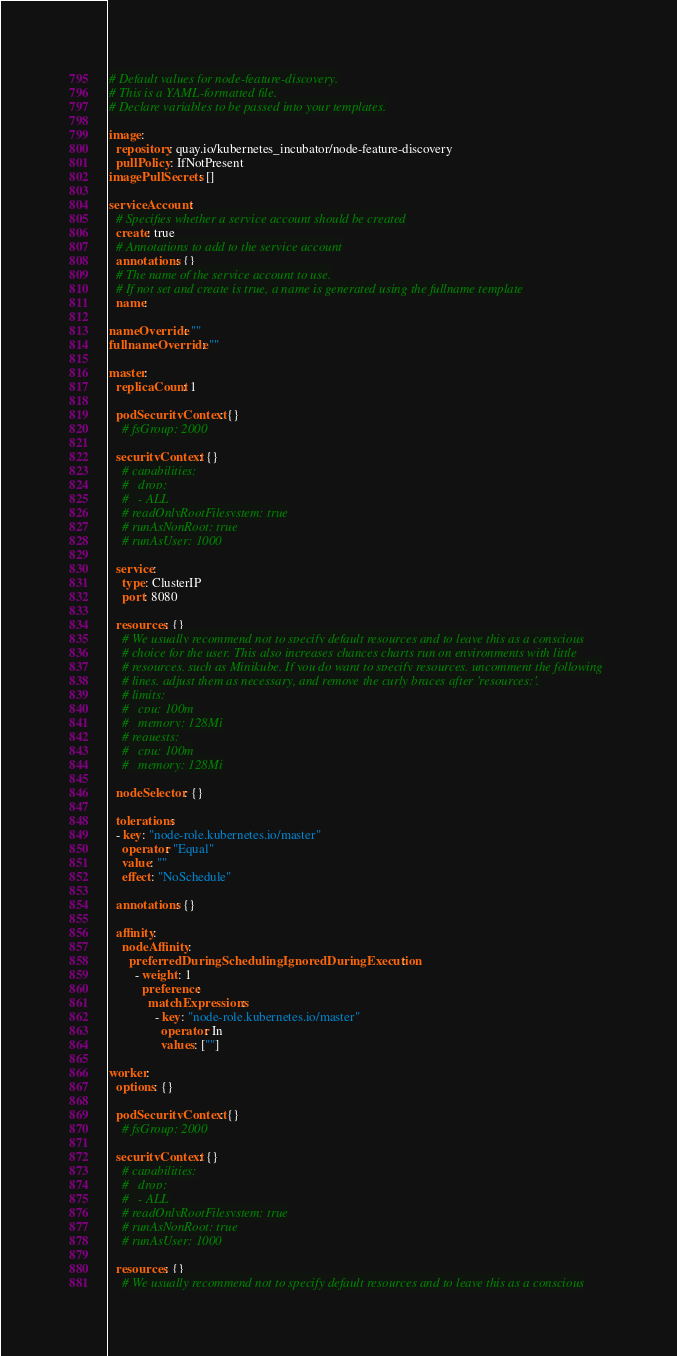<code> <loc_0><loc_0><loc_500><loc_500><_YAML_># Default values for node-feature-discovery.
# This is a YAML-formatted file.
# Declare variables to be passed into your templates.

image:
  repository: quay.io/kubernetes_incubator/node-feature-discovery
  pullPolicy: IfNotPresent
imagePullSecrets: []
  
serviceAccount:
  # Specifies whether a service account should be created
  create: true
  # Annotations to add to the service account
  annotations: {}
  # The name of the service account to use.
  # If not set and create is true, a name is generated using the fullname template
  name:

nameOverride: ""
fullnameOverride: ""

master:
  replicaCount: 1

  podSecurityContext: {}
    # fsGroup: 2000

  securityContext: {}
    # capabilities:
    #   drop:
    #   - ALL
    # readOnlyRootFilesystem: true
    # runAsNonRoot: true
    # runAsUser: 1000

  service:
    type: ClusterIP
    port: 8080

  resources: {}
    # We usually recommend not to specify default resources and to leave this as a conscious
    # choice for the user. This also increases chances charts run on environments with little
    # resources, such as Minikube. If you do want to specify resources, uncomment the following
    # lines, adjust them as necessary, and remove the curly braces after 'resources:'.
    # limits:
    #   cpu: 100m
    #   memory: 128Mi
    # requests:
    #   cpu: 100m
    #   memory: 128Mi

  nodeSelector: {}

  tolerations:
  - key: "node-role.kubernetes.io/master"
    operator: "Equal"
    value: ""
    effect: "NoSchedule"

  annotations: {}

  affinity:
    nodeAffinity:
      preferredDuringSchedulingIgnoredDuringExecution:
        - weight: 1
          preference:
            matchExpressions:
              - key: "node-role.kubernetes.io/master"
                operator: In
                values: [""]

worker:
  options: {}

  podSecurityContext: {}
    # fsGroup: 2000

  securityContext: {}
    # capabilities:
    #   drop:
    #   - ALL
    # readOnlyRootFilesystem: true
    # runAsNonRoot: true
    # runAsUser: 1000

  resources: {}
    # We usually recommend not to specify default resources and to leave this as a conscious</code> 